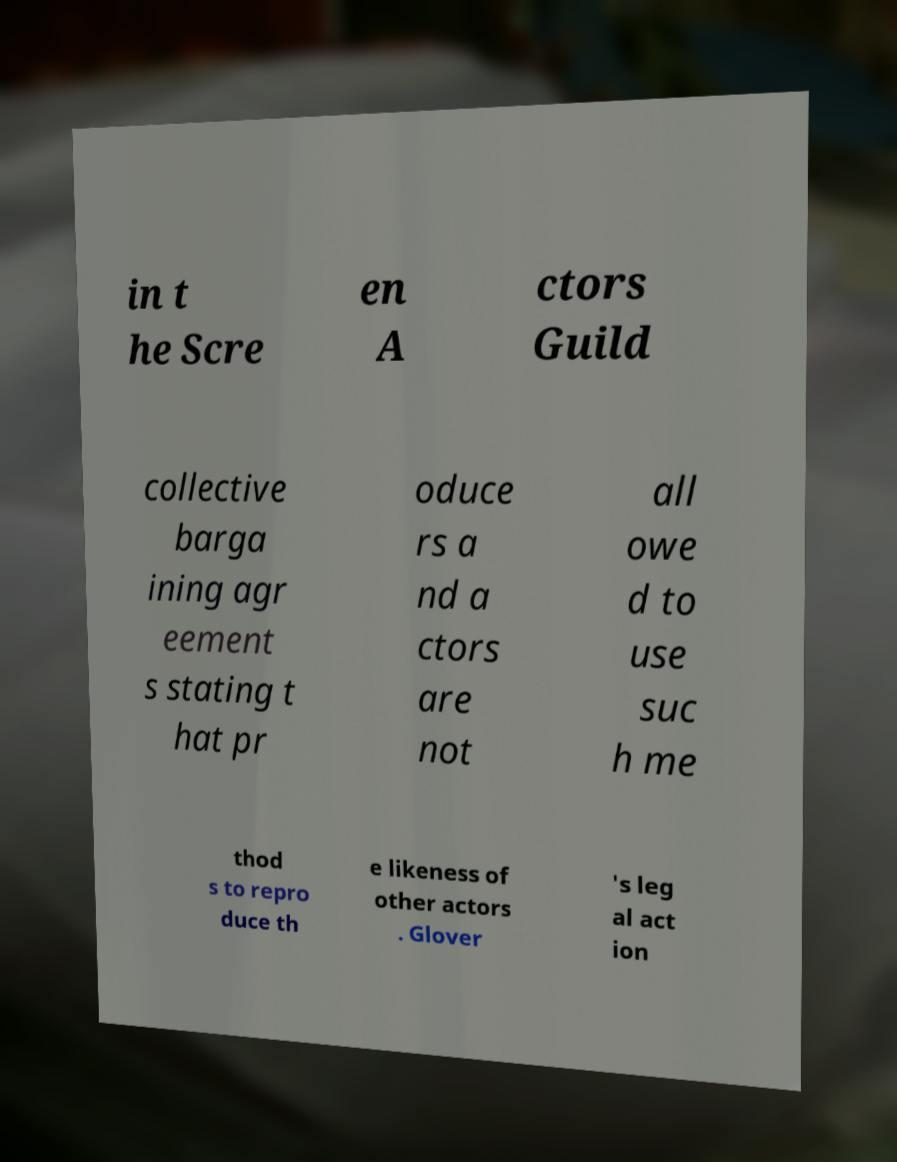I need the written content from this picture converted into text. Can you do that? in t he Scre en A ctors Guild collective barga ining agr eement s stating t hat pr oduce rs a nd a ctors are not all owe d to use suc h me thod s to repro duce th e likeness of other actors . Glover 's leg al act ion 